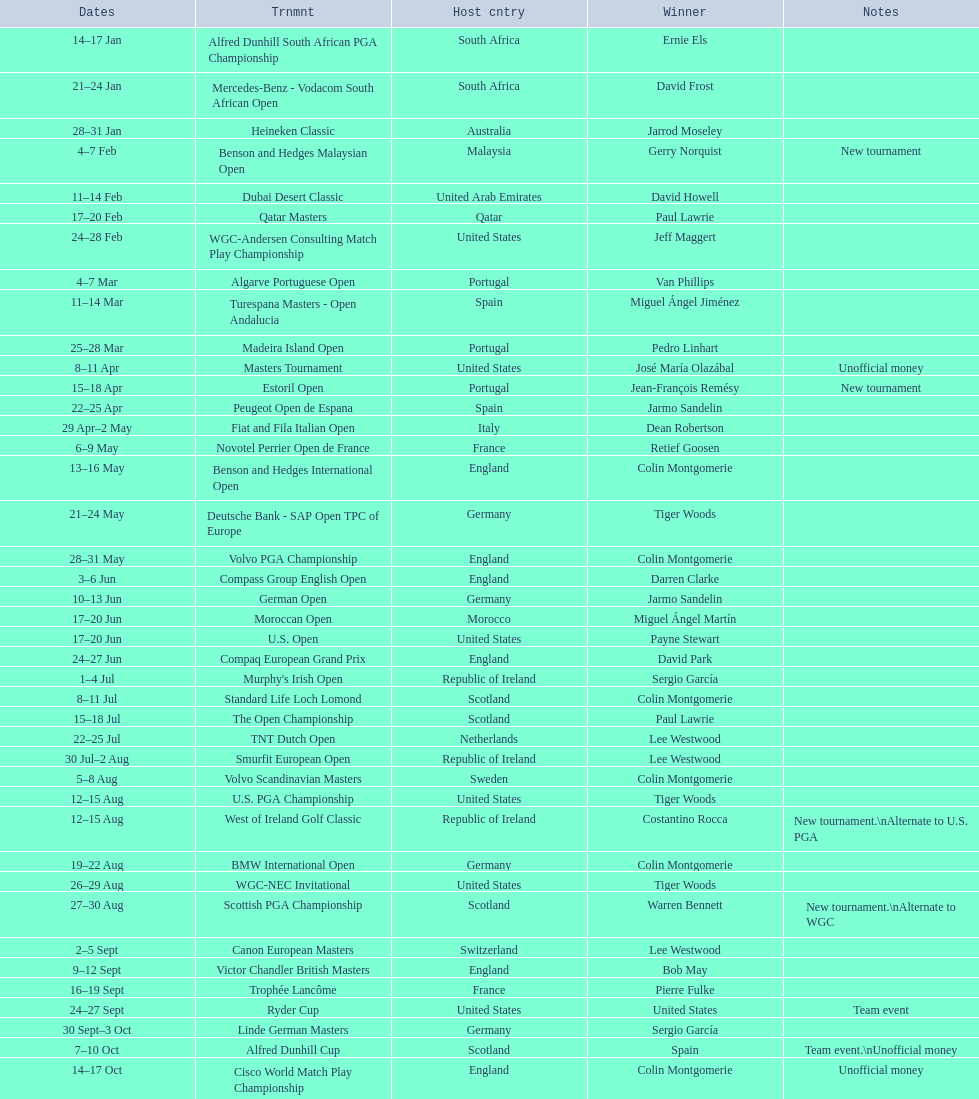How many consecutive times was south africa the host country? 2. 